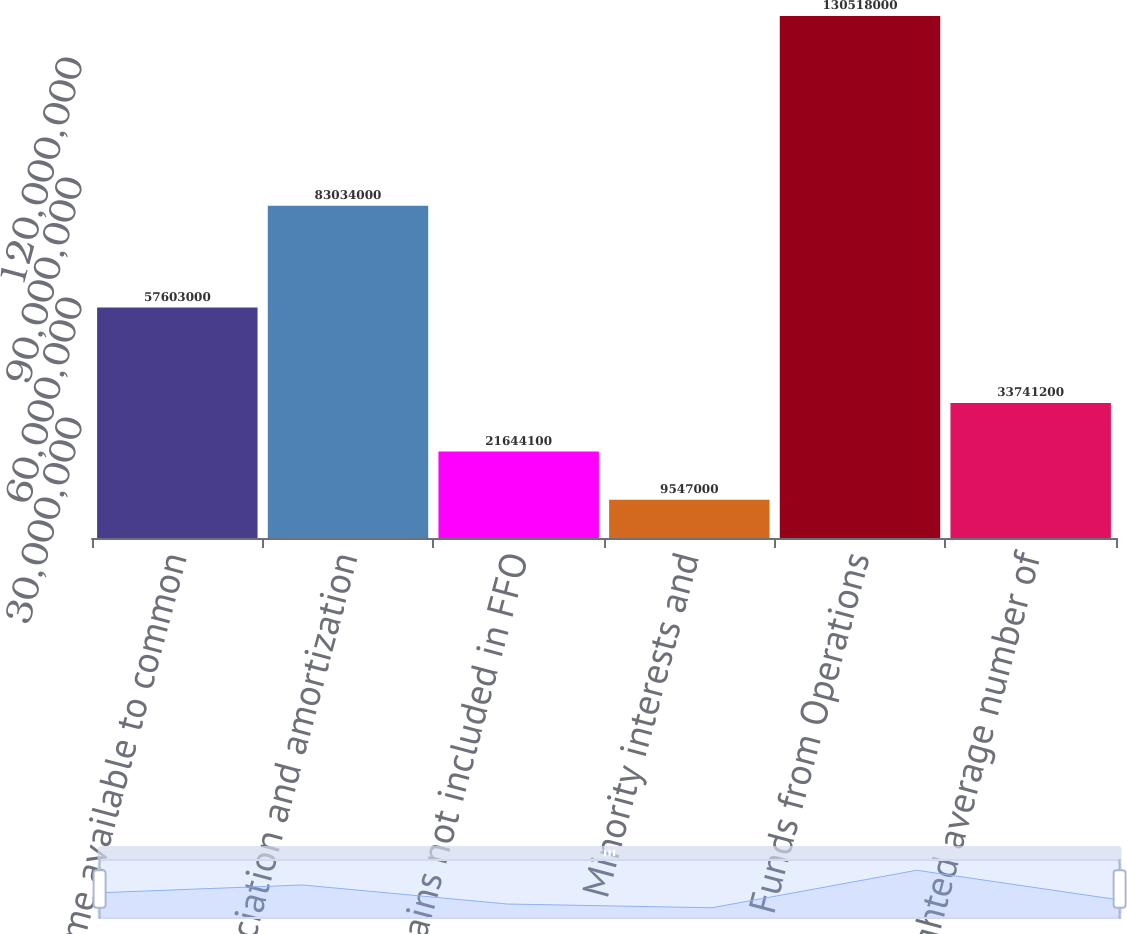Convert chart to OTSL. <chart><loc_0><loc_0><loc_500><loc_500><bar_chart><fcel>Net income available to common<fcel>Depreciation and amortization<fcel>Gains not included in FFO<fcel>Minority interests and<fcel>Funds from Operations<fcel>Weighted average number of<nl><fcel>5.7603e+07<fcel>8.3034e+07<fcel>2.16441e+07<fcel>9.547e+06<fcel>1.30518e+08<fcel>3.37412e+07<nl></chart> 